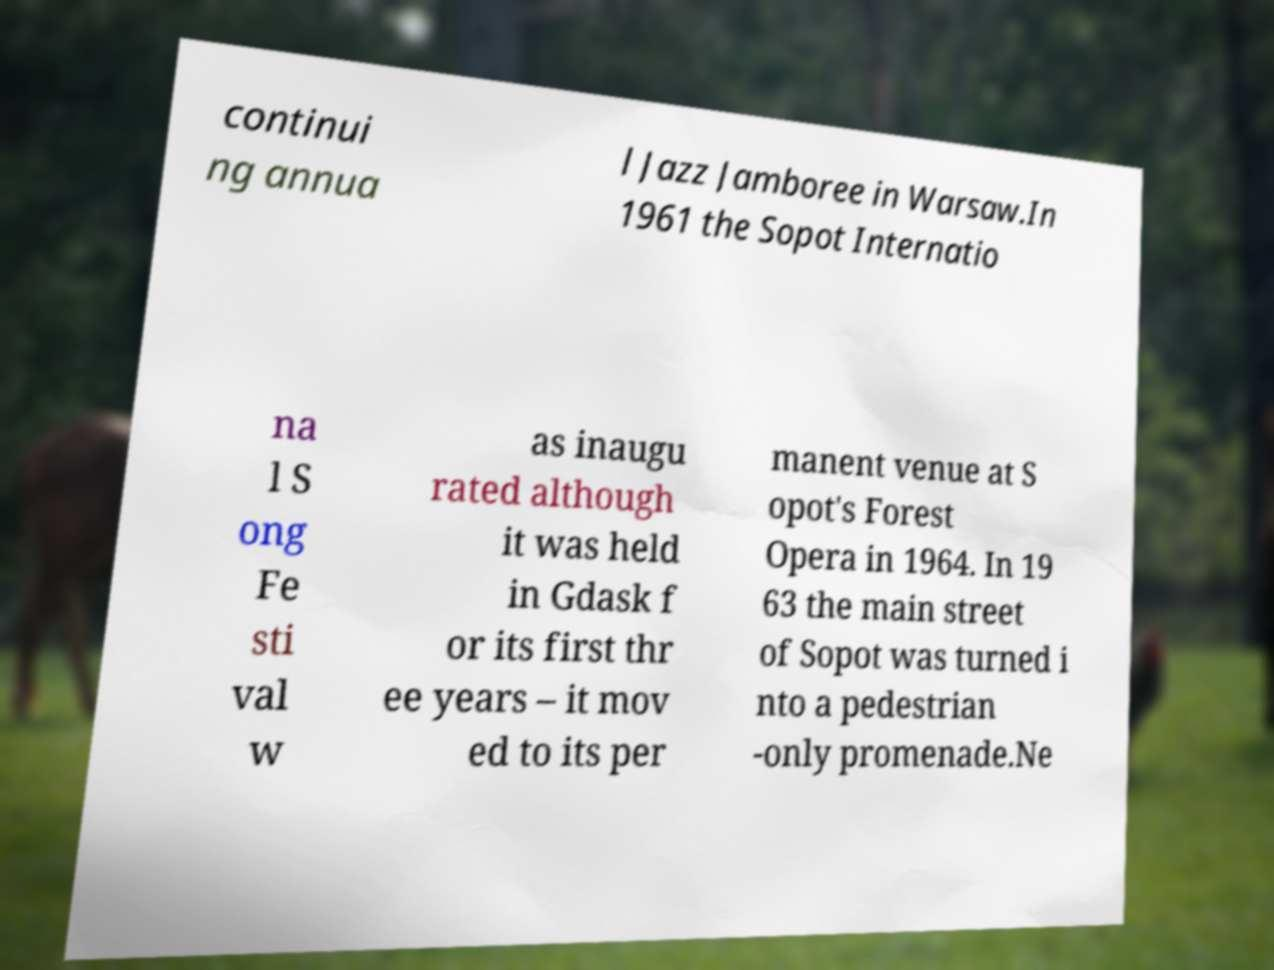Please read and relay the text visible in this image. What does it say? continui ng annua l Jazz Jamboree in Warsaw.In 1961 the Sopot Internatio na l S ong Fe sti val w as inaugu rated although it was held in Gdask f or its first thr ee years – it mov ed to its per manent venue at S opot's Forest Opera in 1964. In 19 63 the main street of Sopot was turned i nto a pedestrian -only promenade.Ne 